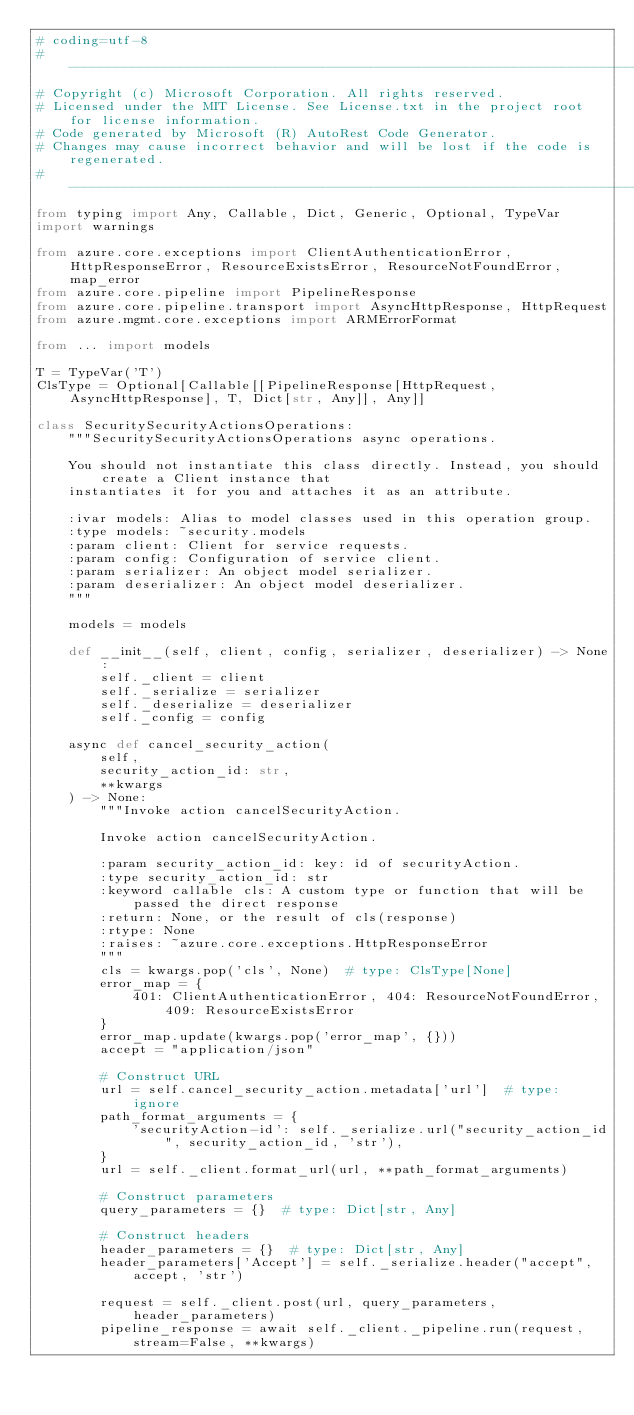Convert code to text. <code><loc_0><loc_0><loc_500><loc_500><_Python_># coding=utf-8
# --------------------------------------------------------------------------
# Copyright (c) Microsoft Corporation. All rights reserved.
# Licensed under the MIT License. See License.txt in the project root for license information.
# Code generated by Microsoft (R) AutoRest Code Generator.
# Changes may cause incorrect behavior and will be lost if the code is regenerated.
# --------------------------------------------------------------------------
from typing import Any, Callable, Dict, Generic, Optional, TypeVar
import warnings

from azure.core.exceptions import ClientAuthenticationError, HttpResponseError, ResourceExistsError, ResourceNotFoundError, map_error
from azure.core.pipeline import PipelineResponse
from azure.core.pipeline.transport import AsyncHttpResponse, HttpRequest
from azure.mgmt.core.exceptions import ARMErrorFormat

from ... import models

T = TypeVar('T')
ClsType = Optional[Callable[[PipelineResponse[HttpRequest, AsyncHttpResponse], T, Dict[str, Any]], Any]]

class SecuritySecurityActionsOperations:
    """SecuritySecurityActionsOperations async operations.

    You should not instantiate this class directly. Instead, you should create a Client instance that
    instantiates it for you and attaches it as an attribute.

    :ivar models: Alias to model classes used in this operation group.
    :type models: ~security.models
    :param client: Client for service requests.
    :param config: Configuration of service client.
    :param serializer: An object model serializer.
    :param deserializer: An object model deserializer.
    """

    models = models

    def __init__(self, client, config, serializer, deserializer) -> None:
        self._client = client
        self._serialize = serializer
        self._deserialize = deserializer
        self._config = config

    async def cancel_security_action(
        self,
        security_action_id: str,
        **kwargs
    ) -> None:
        """Invoke action cancelSecurityAction.

        Invoke action cancelSecurityAction.

        :param security_action_id: key: id of securityAction.
        :type security_action_id: str
        :keyword callable cls: A custom type or function that will be passed the direct response
        :return: None, or the result of cls(response)
        :rtype: None
        :raises: ~azure.core.exceptions.HttpResponseError
        """
        cls = kwargs.pop('cls', None)  # type: ClsType[None]
        error_map = {
            401: ClientAuthenticationError, 404: ResourceNotFoundError, 409: ResourceExistsError
        }
        error_map.update(kwargs.pop('error_map', {}))
        accept = "application/json"

        # Construct URL
        url = self.cancel_security_action.metadata['url']  # type: ignore
        path_format_arguments = {
            'securityAction-id': self._serialize.url("security_action_id", security_action_id, 'str'),
        }
        url = self._client.format_url(url, **path_format_arguments)

        # Construct parameters
        query_parameters = {}  # type: Dict[str, Any]

        # Construct headers
        header_parameters = {}  # type: Dict[str, Any]
        header_parameters['Accept'] = self._serialize.header("accept", accept, 'str')

        request = self._client.post(url, query_parameters, header_parameters)
        pipeline_response = await self._client._pipeline.run(request, stream=False, **kwargs)</code> 